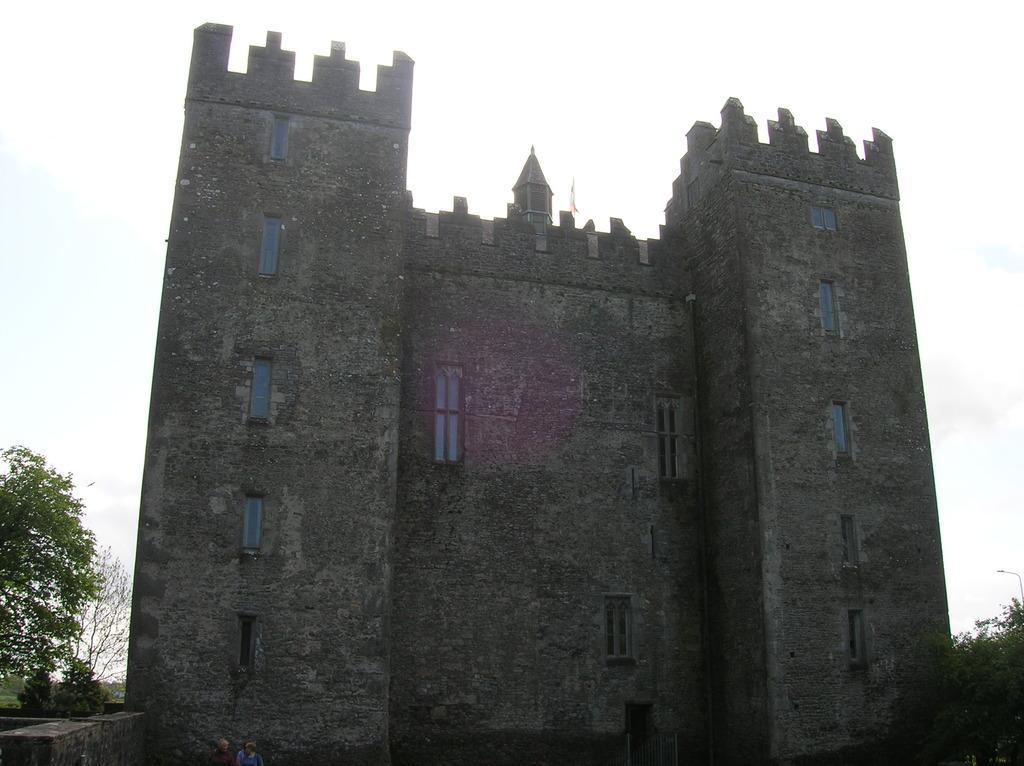In one or two sentences, can you explain what this image depicts? In the image there is a castle with many windows on the land with plants on either side of it and above its sky. 